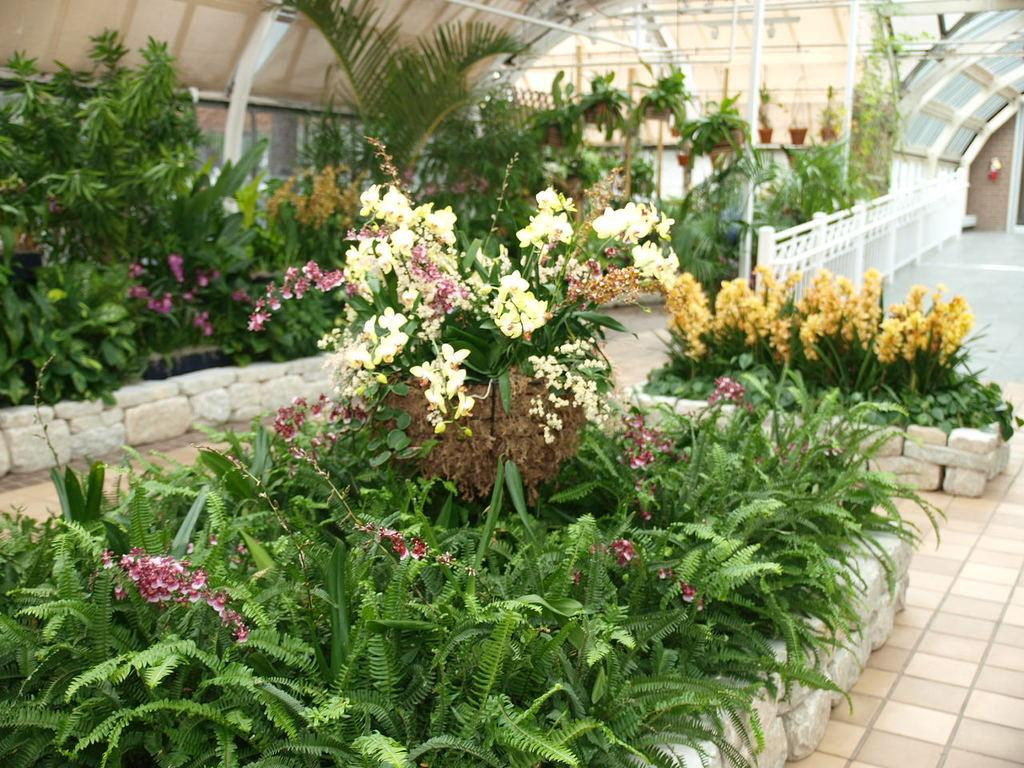What type of plants can be seen in the image? There are grass plants and flower plants in the image. What is the surface beneath the plants? The floor is visible in the image. What type of barrier is present in the image? There is a fence in the image. What are the pots used for in the image? The pots are used to hold the plants. What type of structure can be seen in the image? There is a stone wall in the image. What type of fear can be seen on the face of the van in the image? There is no van present in the image, and therefore no fear can be observed on its face. What type of verse is written on the stone wall in the image? There is no verse written on the stone wall in the image. 